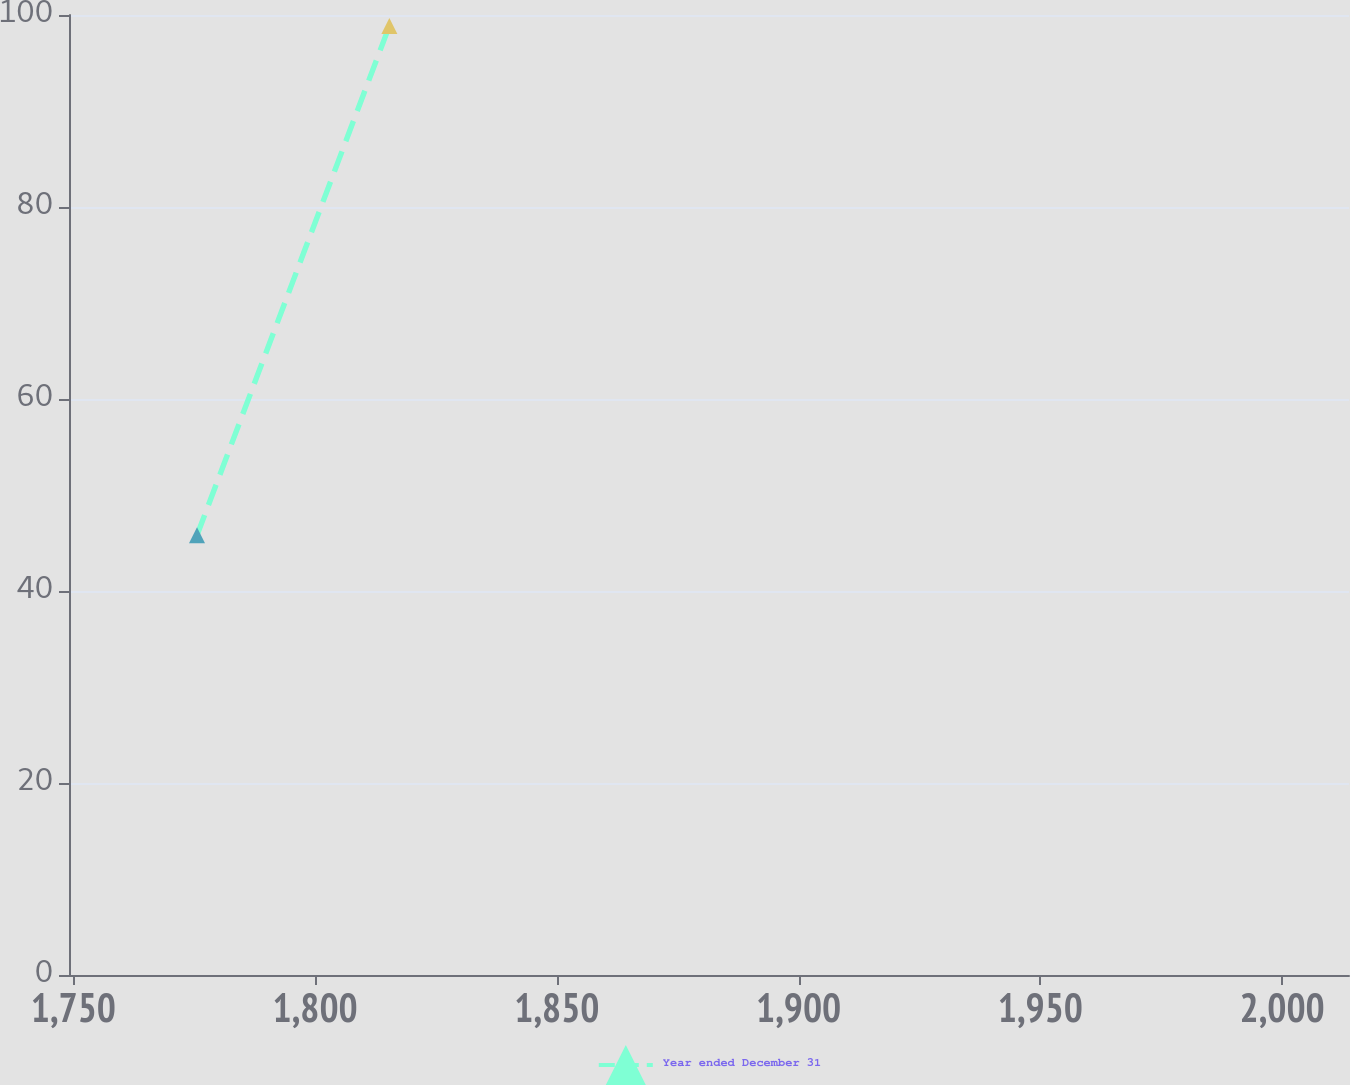<chart> <loc_0><loc_0><loc_500><loc_500><line_chart><ecel><fcel>Year ended December 31<nl><fcel>1775.56<fcel>45.8<nl><fcel>1815.35<fcel>98.86<nl><fcel>2040.31<fcel>159.2<nl></chart> 